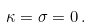<formula> <loc_0><loc_0><loc_500><loc_500>\kappa = \sigma = 0 \, .</formula> 